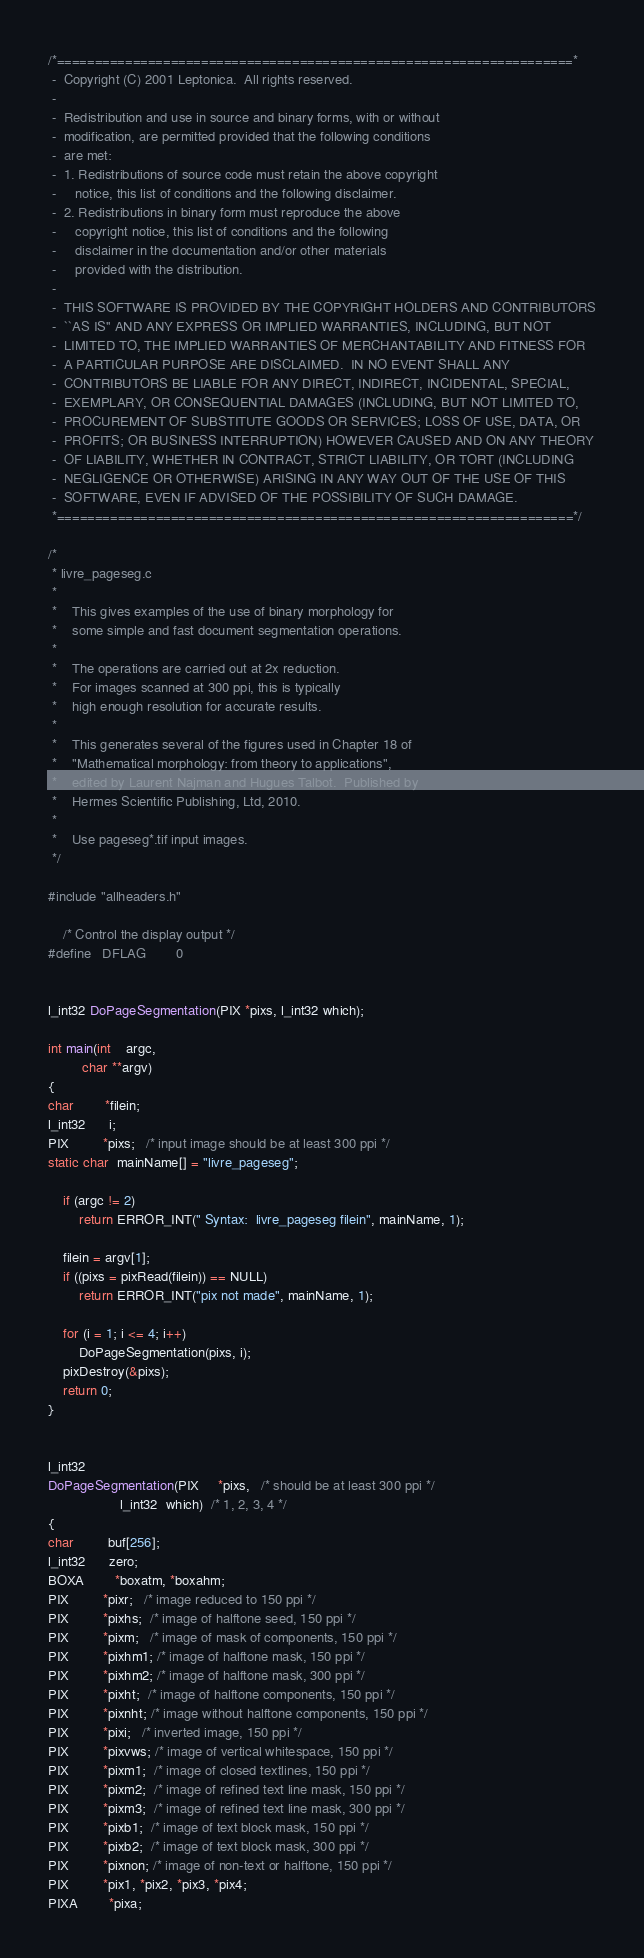<code> <loc_0><loc_0><loc_500><loc_500><_C_>/*====================================================================*
 -  Copyright (C) 2001 Leptonica.  All rights reserved.
 -
 -  Redistribution and use in source and binary forms, with or without
 -  modification, are permitted provided that the following conditions
 -  are met:
 -  1. Redistributions of source code must retain the above copyright
 -     notice, this list of conditions and the following disclaimer.
 -  2. Redistributions in binary form must reproduce the above
 -     copyright notice, this list of conditions and the following
 -     disclaimer in the documentation and/or other materials
 -     provided with the distribution.
 -
 -  THIS SOFTWARE IS PROVIDED BY THE COPYRIGHT HOLDERS AND CONTRIBUTORS
 -  ``AS IS'' AND ANY EXPRESS OR IMPLIED WARRANTIES, INCLUDING, BUT NOT
 -  LIMITED TO, THE IMPLIED WARRANTIES OF MERCHANTABILITY AND FITNESS FOR
 -  A PARTICULAR PURPOSE ARE DISCLAIMED.  IN NO EVENT SHALL ANY
 -  CONTRIBUTORS BE LIABLE FOR ANY DIRECT, INDIRECT, INCIDENTAL, SPECIAL,
 -  EXEMPLARY, OR CONSEQUENTIAL DAMAGES (INCLUDING, BUT NOT LIMITED TO,
 -  PROCUREMENT OF SUBSTITUTE GOODS OR SERVICES; LOSS OF USE, DATA, OR
 -  PROFITS; OR BUSINESS INTERRUPTION) HOWEVER CAUSED AND ON ANY THEORY
 -  OF LIABILITY, WHETHER IN CONTRACT, STRICT LIABILITY, OR TORT (INCLUDING
 -  NEGLIGENCE OR OTHERWISE) ARISING IN ANY WAY OUT OF THE USE OF THIS
 -  SOFTWARE, EVEN IF ADVISED OF THE POSSIBILITY OF SUCH DAMAGE.
 *====================================================================*/

/*
 * livre_pageseg.c
 *
 *    This gives examples of the use of binary morphology for
 *    some simple and fast document segmentation operations.
 *
 *    The operations are carried out at 2x reduction.
 *    For images scanned at 300 ppi, this is typically
 *    high enough resolution for accurate results.
 *
 *    This generates several of the figures used in Chapter 18 of
 *    "Mathematical morphology: from theory to applications",
 *    edited by Laurent Najman and Hugues Talbot.  Published by
 *    Hermes Scientific Publishing, Ltd, 2010.
 *
 *    Use pageseg*.tif input images.
 */

#include "allheaders.h"

    /* Control the display output */
#define   DFLAG        0


l_int32 DoPageSegmentation(PIX *pixs, l_int32 which);

int main(int    argc,
         char **argv)
{
char        *filein;
l_int32      i;
PIX         *pixs;   /* input image should be at least 300 ppi */
static char  mainName[] = "livre_pageseg";

    if (argc != 2)
        return ERROR_INT(" Syntax:  livre_pageseg filein", mainName, 1);

    filein = argv[1];
    if ((pixs = pixRead(filein)) == NULL)
        return ERROR_INT("pix not made", mainName, 1);

    for (i = 1; i <= 4; i++)
        DoPageSegmentation(pixs, i);
    pixDestroy(&pixs);
    return 0;
}


l_int32
DoPageSegmentation(PIX     *pixs,   /* should be at least 300 ppi */
                   l_int32  which)  /* 1, 2, 3, 4 */
{
char         buf[256];
l_int32      zero;
BOXA        *boxatm, *boxahm;
PIX         *pixr;   /* image reduced to 150 ppi */
PIX         *pixhs;  /* image of halftone seed, 150 ppi */
PIX         *pixm;   /* image of mask of components, 150 ppi */
PIX         *pixhm1; /* image of halftone mask, 150 ppi */
PIX         *pixhm2; /* image of halftone mask, 300 ppi */
PIX         *pixht;  /* image of halftone components, 150 ppi */
PIX         *pixnht; /* image without halftone components, 150 ppi */
PIX         *pixi;   /* inverted image, 150 ppi */
PIX         *pixvws; /* image of vertical whitespace, 150 ppi */
PIX         *pixm1;  /* image of closed textlines, 150 ppi */
PIX         *pixm2;  /* image of refined text line mask, 150 ppi */
PIX         *pixm3;  /* image of refined text line mask, 300 ppi */
PIX         *pixb1;  /* image of text block mask, 150 ppi */
PIX         *pixb2;  /* image of text block mask, 300 ppi */
PIX         *pixnon; /* image of non-text or halftone, 150 ppi */
PIX         *pix1, *pix2, *pix3, *pix4;
PIXA        *pixa;</code> 